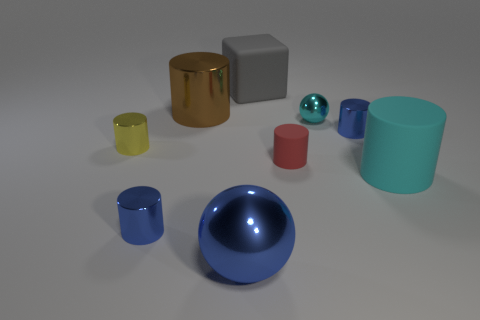There is a large cylinder to the right of the large brown object; is it the same color as the ball behind the big blue metallic ball?
Give a very brief answer. Yes. Are there any tiny blue metallic objects of the same shape as the brown thing?
Keep it short and to the point. Yes. What number of other things are the same color as the big sphere?
Your response must be concise. 2. There is a shiny sphere that is behind the large cyan cylinder that is in front of the metallic sphere that is on the right side of the tiny rubber thing; what is its color?
Provide a short and direct response. Cyan. Are there the same number of blue metallic cylinders on the left side of the red matte cylinder and big gray things?
Offer a very short reply. Yes. Does the shiny object that is behind the cyan shiny sphere have the same size as the rubber block?
Provide a succinct answer. Yes. What number of green matte cylinders are there?
Offer a terse response. 0. What number of large matte objects are to the left of the large cyan object and to the right of the large gray thing?
Your response must be concise. 0. Are there any large purple things made of the same material as the small sphere?
Offer a very short reply. No. The small red thing in front of the blue object to the right of the big gray matte cube is made of what material?
Ensure brevity in your answer.  Rubber. 